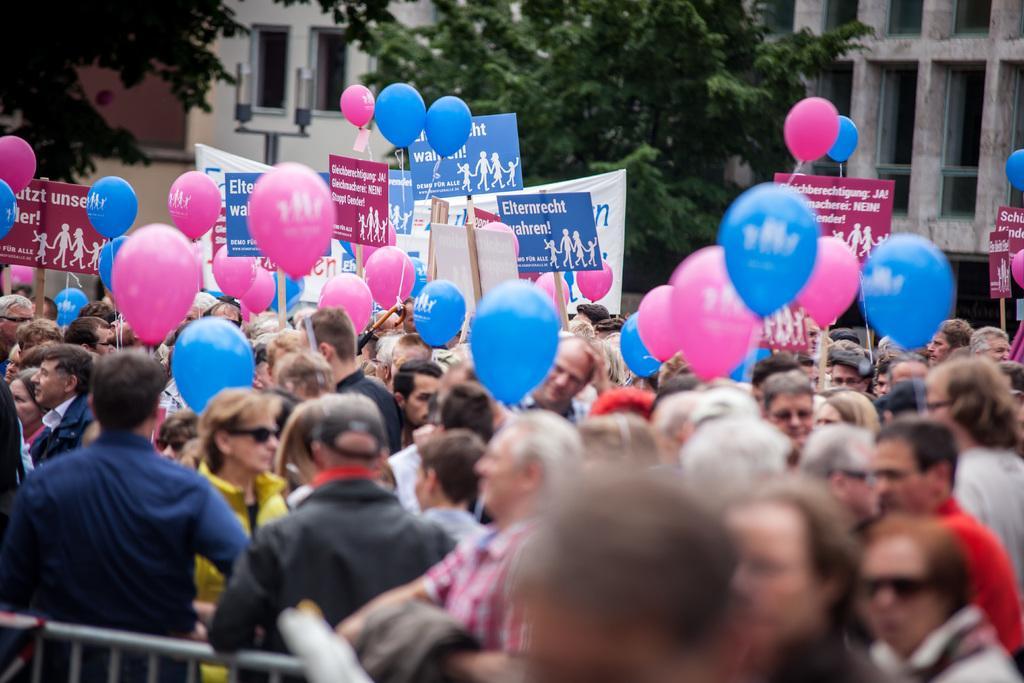Describe this image in one or two sentences. In the picture I can see a group of people are standing on the ground, among them some are holding placards which has something written on them and balloons. I can also see fence, buildings, trees and some other objects. 